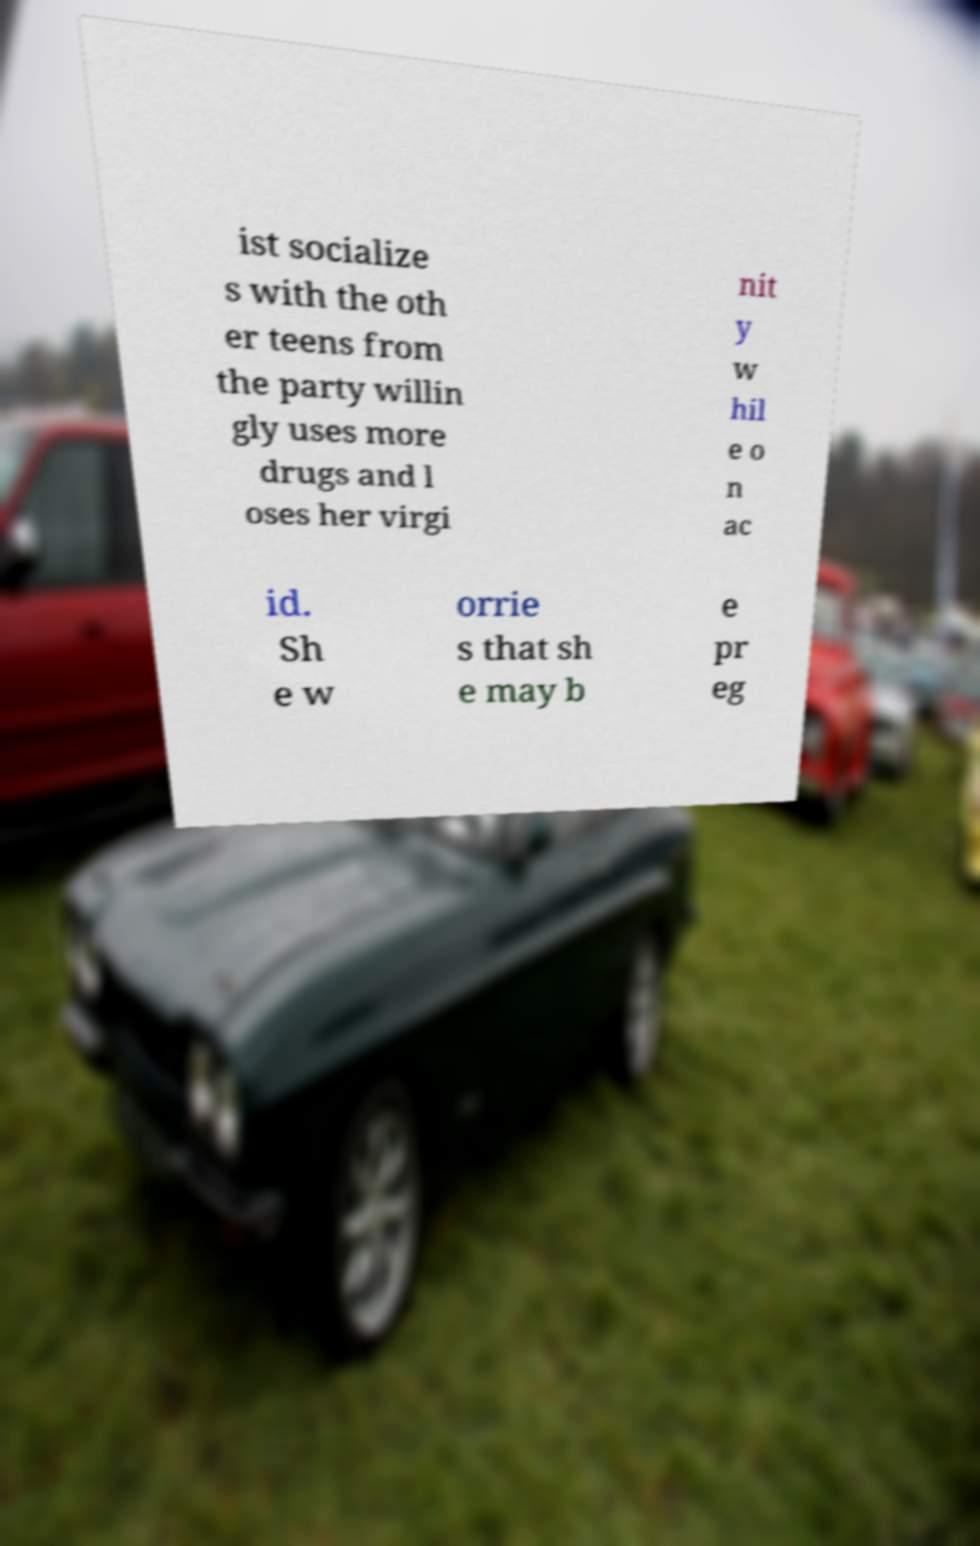Could you extract and type out the text from this image? ist socialize s with the oth er teens from the party willin gly uses more drugs and l oses her virgi nit y w hil e o n ac id. Sh e w orrie s that sh e may b e pr eg 